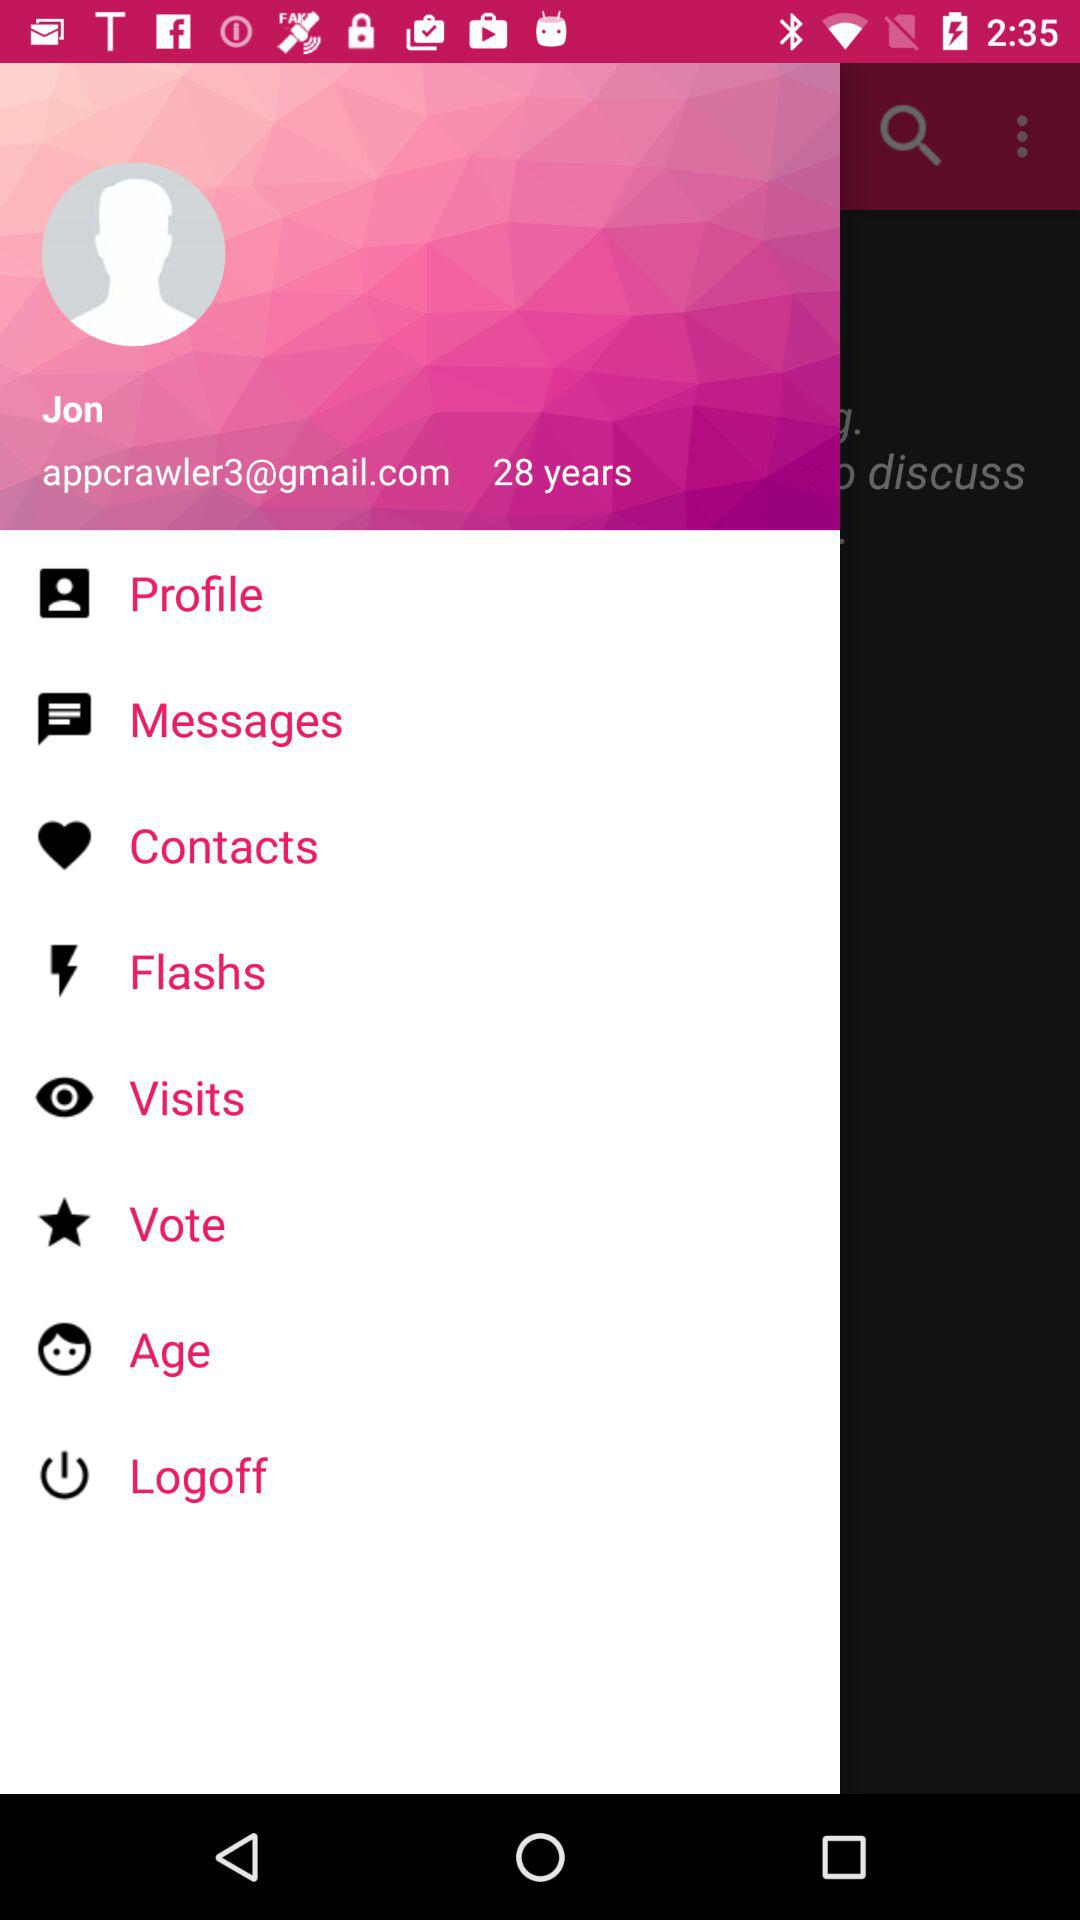What is the email address? The email address is appcrawler3@gmail.com. 